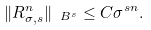<formula> <loc_0><loc_0><loc_500><loc_500>\| R _ { \sigma , s } ^ { n } \| _ { \ B ^ { s } } \leq C \sigma ^ { s n } .</formula> 